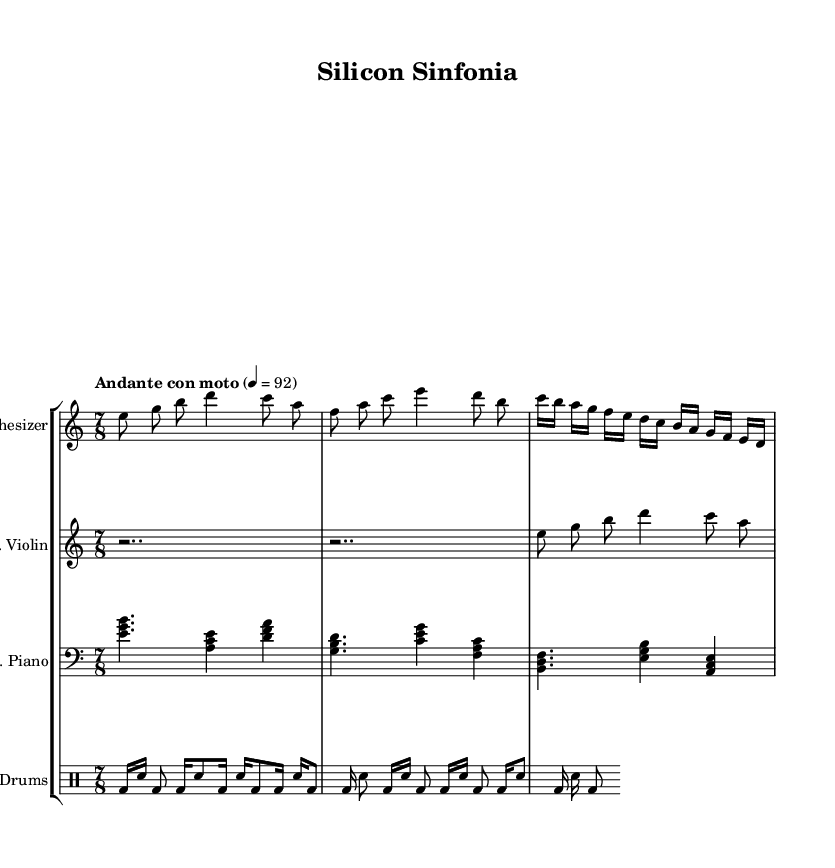What is the time signature of this music? The time signature displayed at the beginning of the sheet music is 7/8, indicating seven beats per measure with an eighth note receiving one beat.
Answer: 7/8 What is the tempo marking for this piece? The tempo marking states "Andante con moto," which indicates a moderately slow tempo with some movement, typically around 92 beats per minute.
Answer: Andante con moto How many different instruments are featured in this composition? The score includes a synthesizer, electric violin, prepared piano, and electronic drum kit, totaling four distinct instruments.
Answer: Four What are the primary themes represented in the synthesizer part? The synthesizer part features a blend of rising and falling melodic lines, suggesting innovation and progress through the evolution of the motifs presented.
Answer: Innovation and progress What is the rhythmic pattern used by the electronic drum kit? The pattern alternates between bass drum and snare, utilizing a mix of sixteenth and eighth notes, creating a consistent and driving rhythm throughout the measure.
Answer: Alternating bass and snare Which instrument plays a continuous rhythm at the beginning? The electric violin starts with rests before entering, but initially, it has two bars of silence, marking it as not presenting an active rhythm from the start.
Answer: Electric Violin 